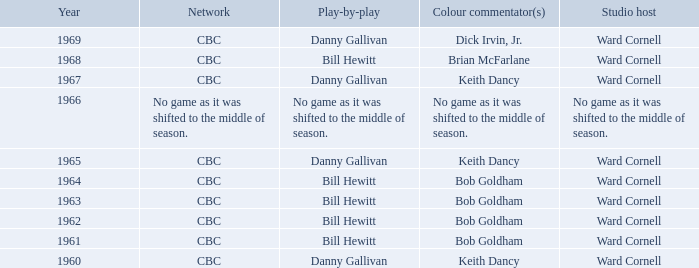Were the color commentators who worked with Bill Hewitt doing the play-by-play? Brian McFarlane, Bob Goldham, Bob Goldham, Bob Goldham, Bob Goldham. 